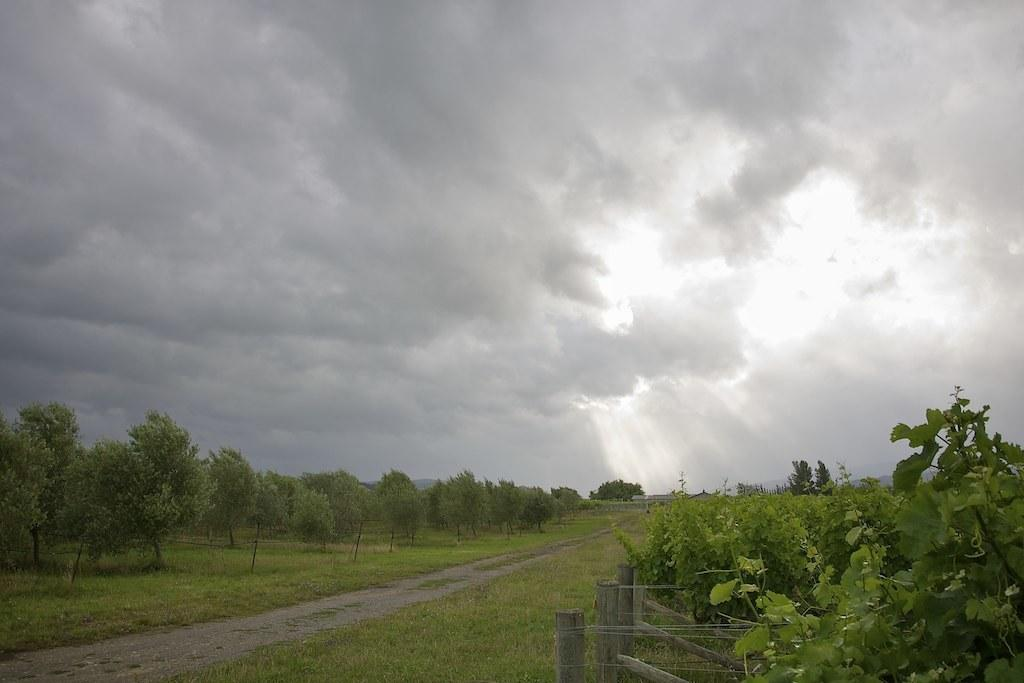What is located on the left side of the image? The provided facts do not specify any objects or subjects on the left side of the image. What is visible at the top of the image? The sky is visible at the top of the image. What is the condition of the sky in the image? The sky is cloudy in the image. What type of tax can be seen being collected in the image? There is no reference to tax or any form of collection in the image. What scent is associated with the clouds in the image? The image does not provide any information about the scent of the clouds. 